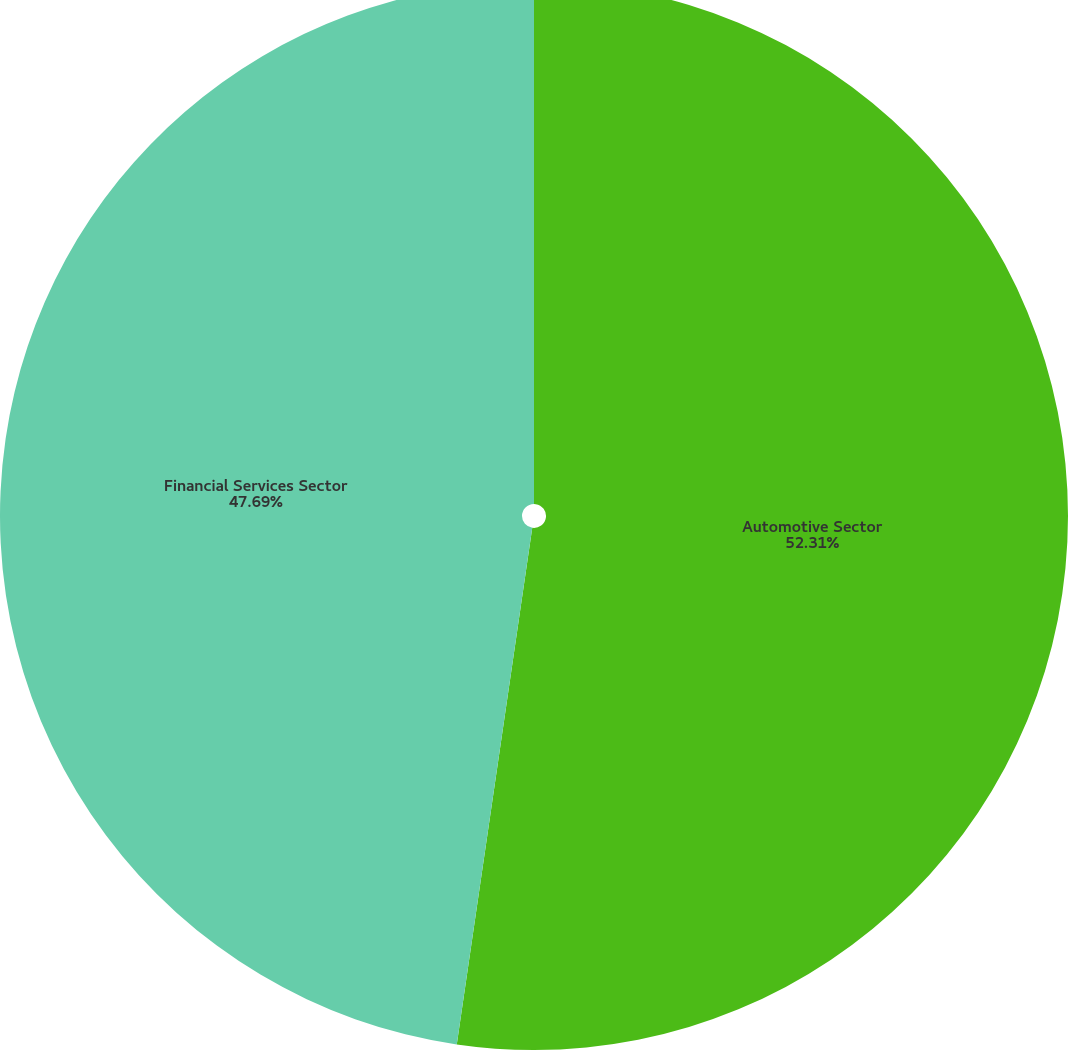Convert chart to OTSL. <chart><loc_0><loc_0><loc_500><loc_500><pie_chart><fcel>Automotive Sector<fcel>Financial Services Sector<nl><fcel>52.31%<fcel>47.69%<nl></chart> 